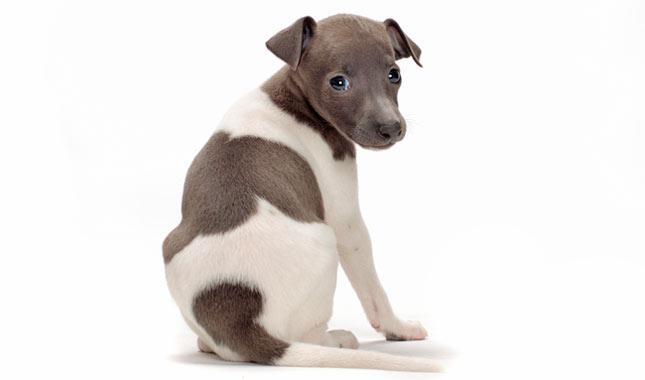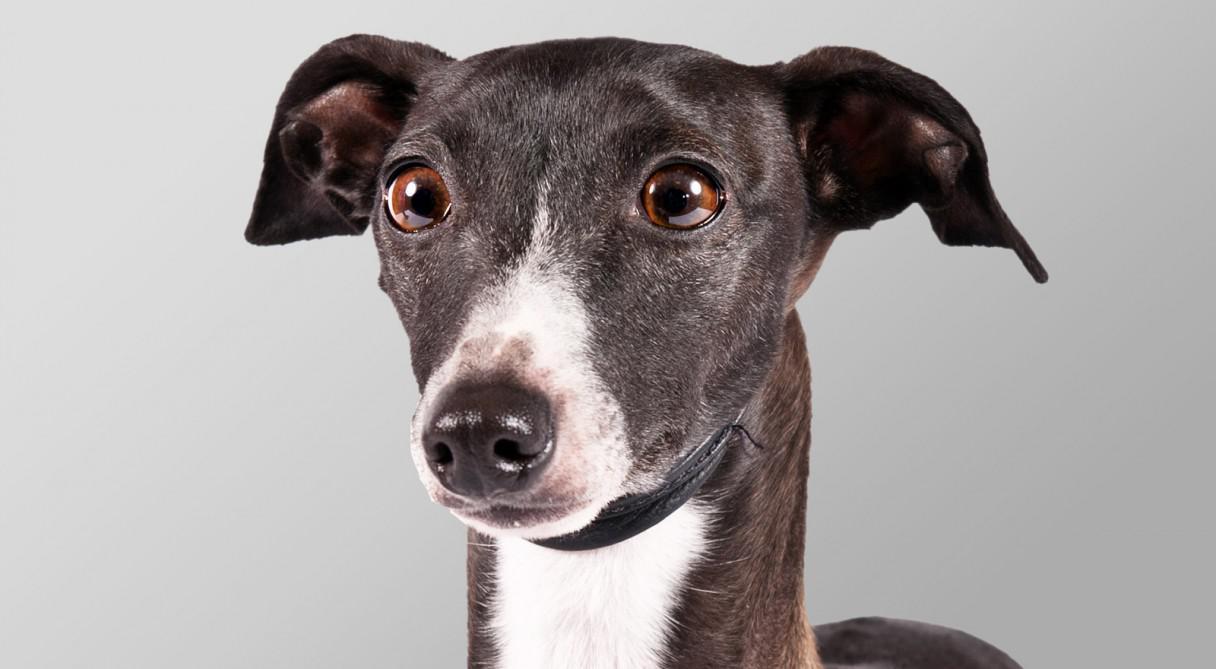The first image is the image on the left, the second image is the image on the right. Evaluate the accuracy of this statement regarding the images: "The dog in one of the images is on a cemented area outside.". Is it true? Answer yes or no. No. The first image is the image on the left, the second image is the image on the right. Examine the images to the left and right. Is the description "An image shows a dog wearing a garment with a turtleneck." accurate? Answer yes or no. No. The first image is the image on the left, the second image is the image on the right. For the images displayed, is the sentence "At least one of the dogs is standing on all fours." factually correct? Answer yes or no. No. 